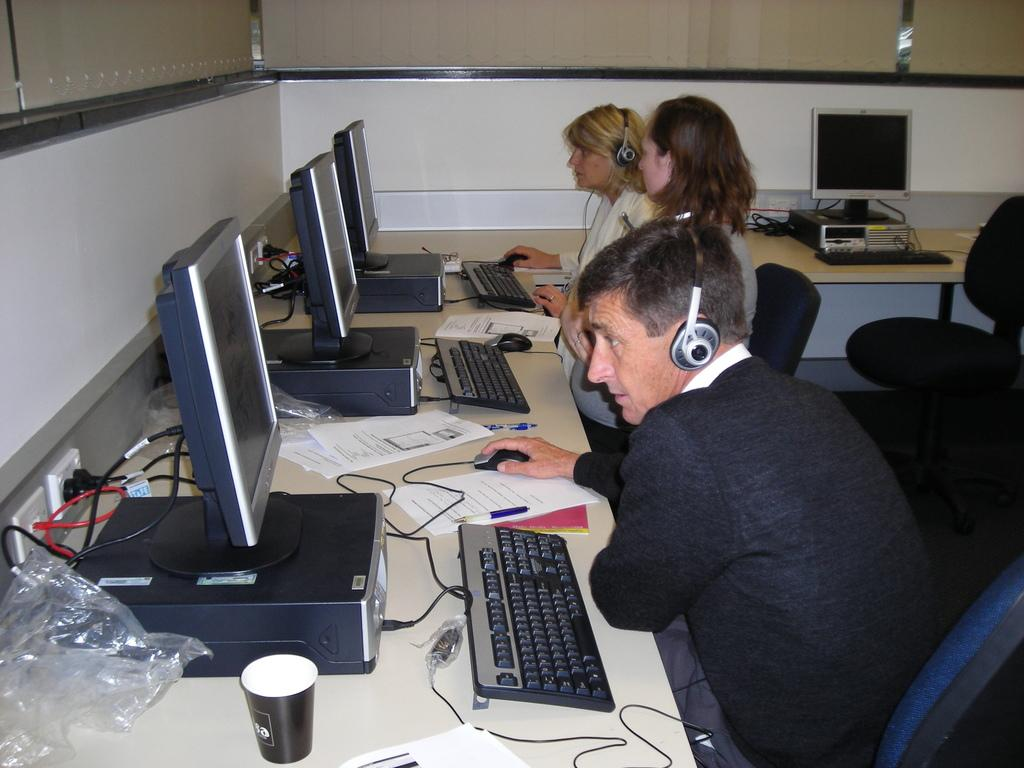What are the persons in the image doing? The persons in the image are sitting on chairs in front of a table. What can be seen on the persons' heads? The persons are wearing headsets. What electronic devices are on the table? There is a CPU, a monitor, a keyboard, and a mouse on the table. What can be seen on the table that is not an electronic device? There is a glass, a cover, papers, and a pen on the table. Can you tell me what type of gun is on the table in the image? There is no gun present in the image; the objects on the table include a CPU, a monitor, a keyboard, a mouse, a glass, a cover, papers, and a pen. 